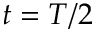Convert formula to latex. <formula><loc_0><loc_0><loc_500><loc_500>t = T / 2</formula> 